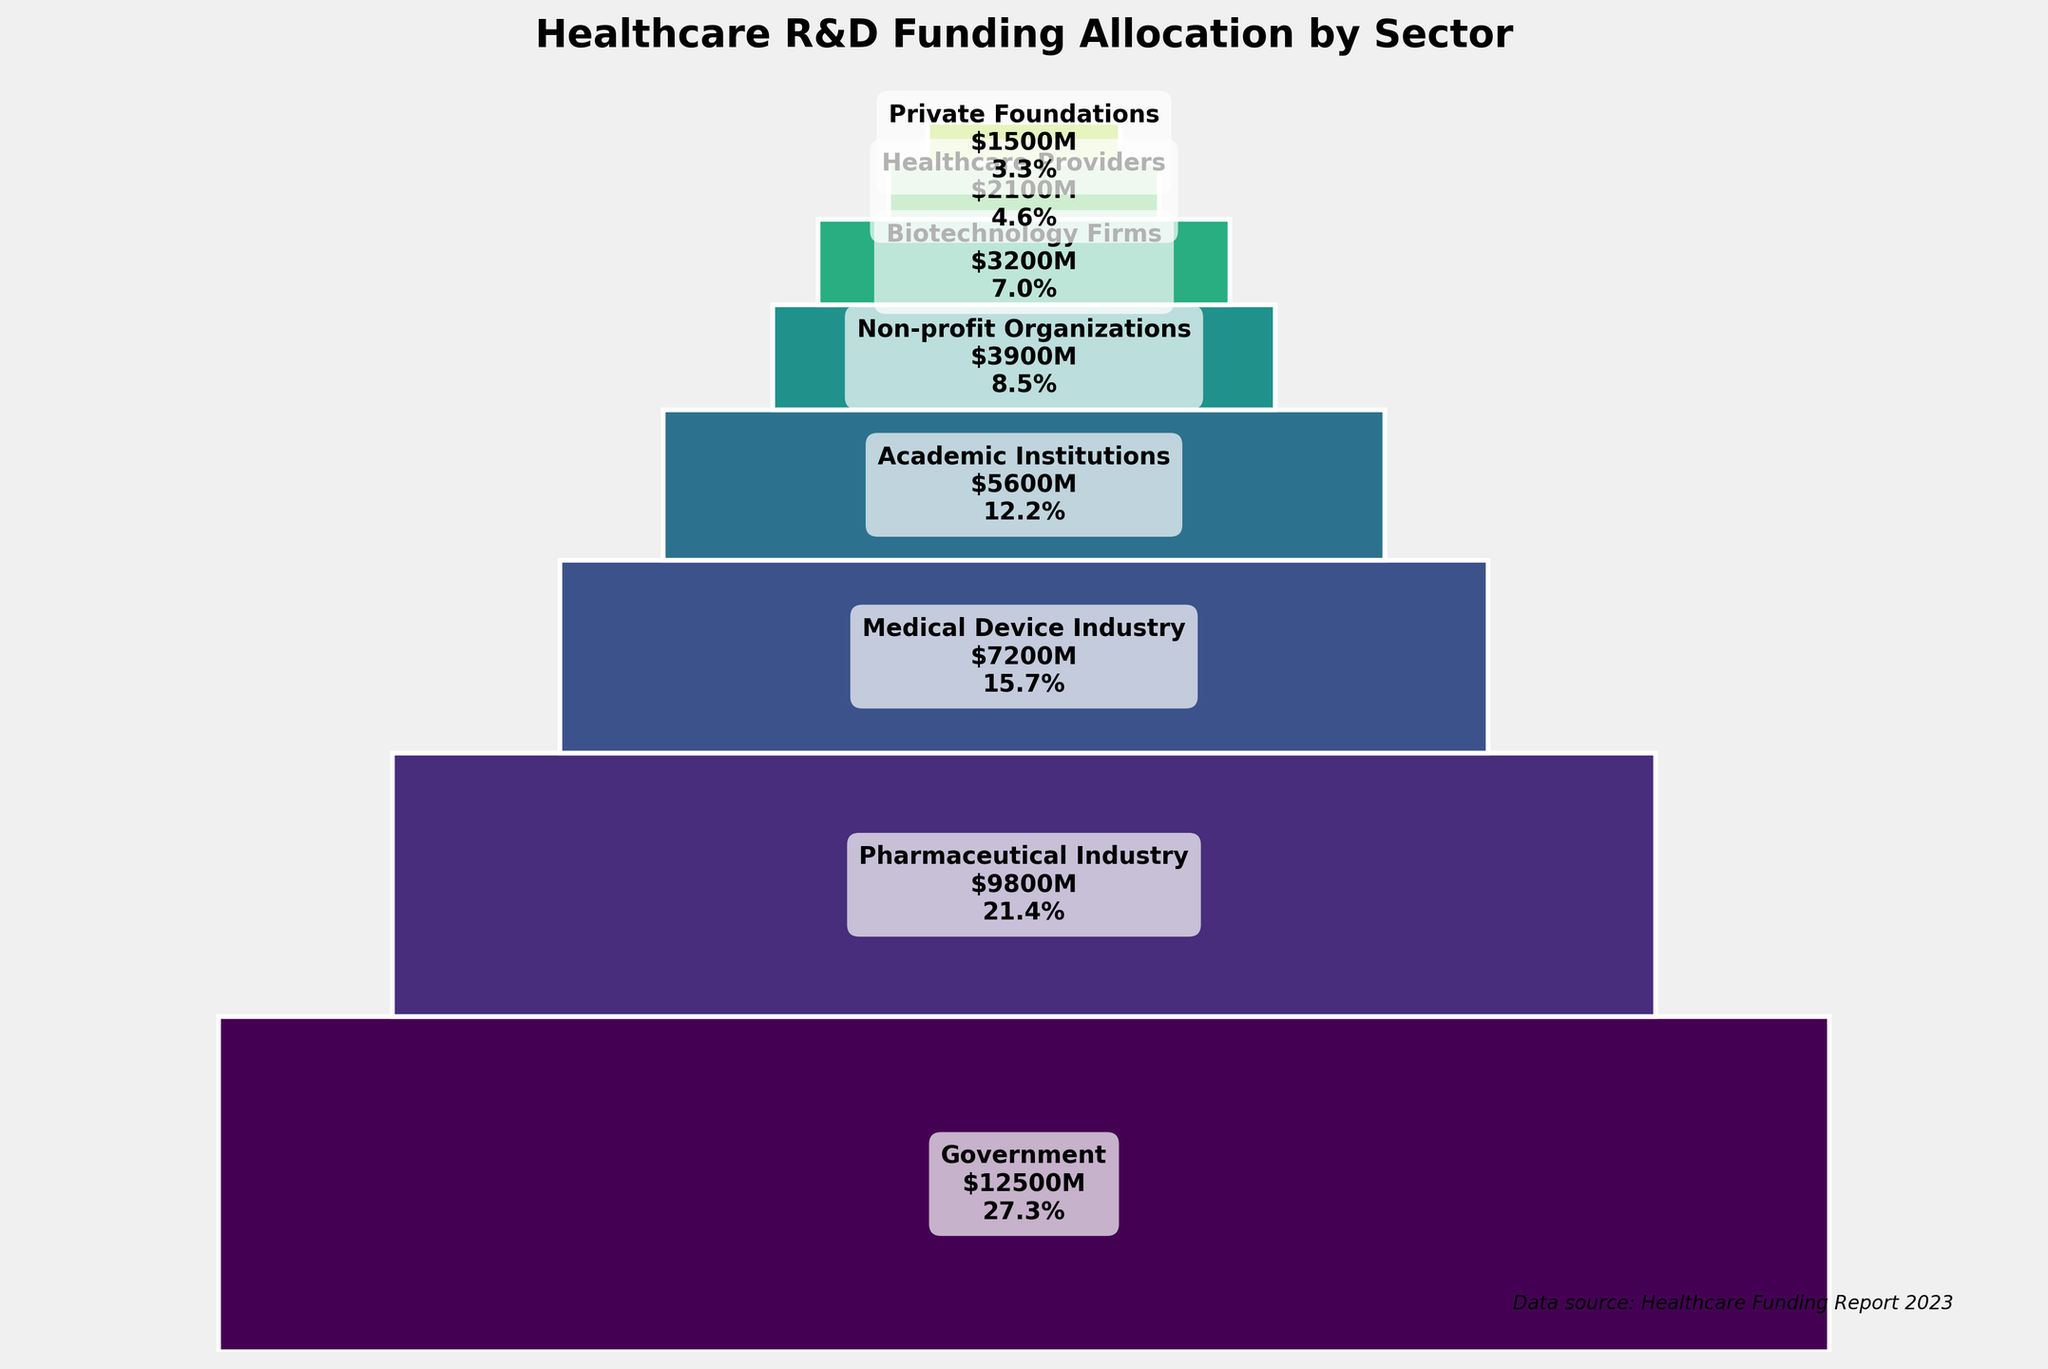What is the title of the funnel chart? The title is located at the top of the chart and reads "Healthcare R&D Funding Allocation by Sector".
Answer: Healthcare R&D Funding Allocation by Sector Which sector has the highest funding allocation? The sector with the highest funding allocation is located at the top of the funnel chart and has the largest area.
Answer: Government What percentage of the total funding is allocated to the Government sector? The percentage for each sector is indicated next to its funding amount on the chart. Government is at the top with the label "$12500M\n39.9%".
Answer: 39.9% What is the funding amount for the Medical Device Industry sector? The funding amount is shown inside each segment of the funnel chart. The Medical Device Industry is labeled with "$7200M".
Answer: $7200M How many sectors in total are represented in the funnel chart? Count the number of distinct segments in the funnel chart, each representing a sector.
Answer: 8 Which sector has the lowest funding allocation? The sector with the lowest funding allocation is located at the bottom of the funnel chart and has the smallest area.
Answer: Private Foundations How much more funding does the Government sector receive compared to the Biotechnology Firms? Subtract the funding amount for Biotechnology Firms from the funding amount for Government. This is $12500M - $3200M.
Answer: $9300M What is the total funding amount allocated to the top three sectors combined? Add the funding amounts for the Government, Pharmaceutical Industry, and Medical Device Industry. This is $12500M + $9800M + $7200M.
Answer: $29500M What is the average funding amount allocated to each sector? Calculate the average by summing the total funding amounts and dividing by the number of sectors. This is ($12500M + $9800M + $7200M + $5600M + $3900M + $3200M + $2100M + $1500M) / 8.
Answer: $6125M Which sector accounts for the third highest funding allocation? The third segment from the top of the funnel chart represents the sector with the third highest funding allocation. This is the Medical Device Industry.
Answer: Medical Device Industry 